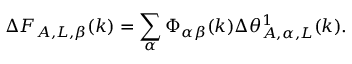Convert formula to latex. <formula><loc_0><loc_0><loc_500><loc_500>\Delta F _ { A , L , \beta } ( k ) = \sum _ { \alpha } \Phi _ { \alpha \beta } ( k ) \Delta \theta _ { A , \alpha , L } ^ { 1 } ( k ) .</formula> 